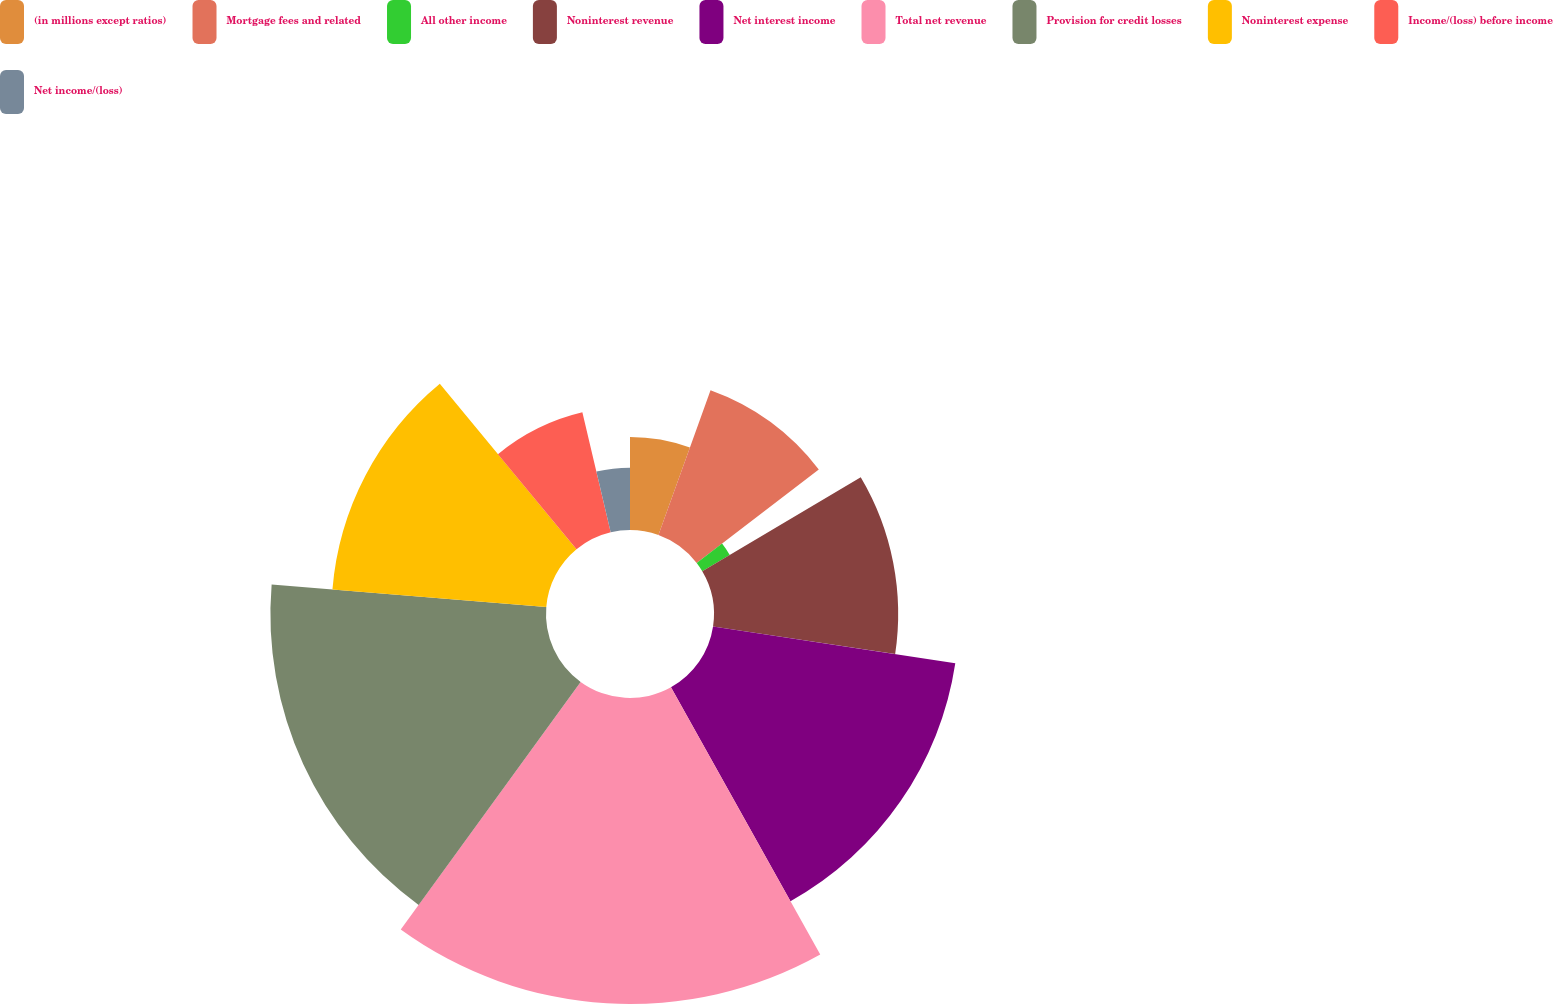<chart> <loc_0><loc_0><loc_500><loc_500><pie_chart><fcel>(in millions except ratios)<fcel>Mortgage fees and related<fcel>All other income<fcel>Noninterest revenue<fcel>Net interest income<fcel>Total net revenue<fcel>Provision for credit losses<fcel>Noninterest expense<fcel>Income/(loss) before income<fcel>Net income/(loss)<nl><fcel>5.5%<fcel>9.1%<fcel>1.89%<fcel>10.9%<fcel>14.5%<fcel>18.11%<fcel>16.31%<fcel>12.7%<fcel>7.3%<fcel>3.69%<nl></chart> 